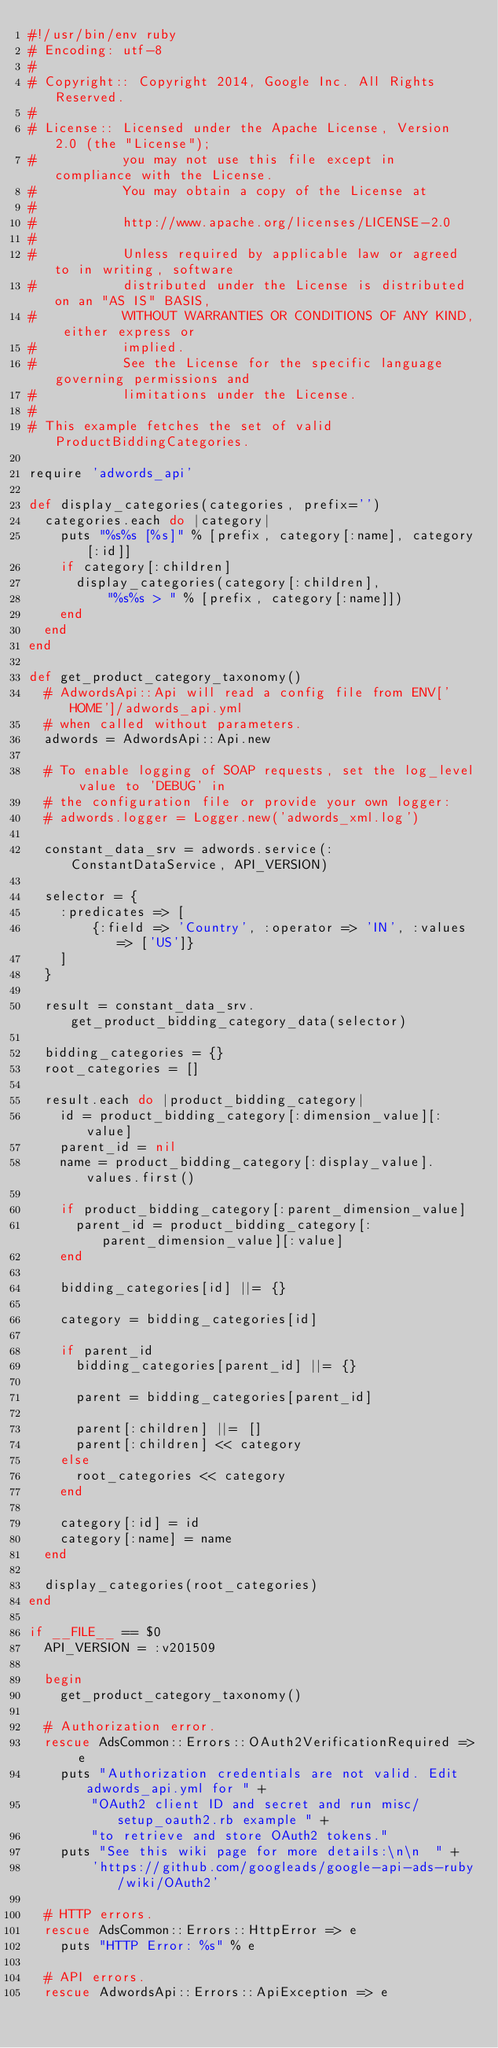Convert code to text. <code><loc_0><loc_0><loc_500><loc_500><_Ruby_>#!/usr/bin/env ruby
# Encoding: utf-8
#
# Copyright:: Copyright 2014, Google Inc. All Rights Reserved.
#
# License:: Licensed under the Apache License, Version 2.0 (the "License");
#           you may not use this file except in compliance with the License.
#           You may obtain a copy of the License at
#
#           http://www.apache.org/licenses/LICENSE-2.0
#
#           Unless required by applicable law or agreed to in writing, software
#           distributed under the License is distributed on an "AS IS" BASIS,
#           WITHOUT WARRANTIES OR CONDITIONS OF ANY KIND, either express or
#           implied.
#           See the License for the specific language governing permissions and
#           limitations under the License.
#
# This example fetches the set of valid ProductBiddingCategories.

require 'adwords_api'

def display_categories(categories, prefix='')
  categories.each do |category|
    puts "%s%s [%s]" % [prefix, category[:name], category[:id]]
    if category[:children]
      display_categories(category[:children],
          "%s%s > " % [prefix, category[:name]])
    end
  end
end

def get_product_category_taxonomy()
  # AdwordsApi::Api will read a config file from ENV['HOME']/adwords_api.yml
  # when called without parameters.
  adwords = AdwordsApi::Api.new

  # To enable logging of SOAP requests, set the log_level value to 'DEBUG' in
  # the configuration file or provide your own logger:
  # adwords.logger = Logger.new('adwords_xml.log')

  constant_data_srv = adwords.service(:ConstantDataService, API_VERSION)

  selector = {
    :predicates => [
        {:field => 'Country', :operator => 'IN', :values => ['US']}
    ]
  }

  result = constant_data_srv.get_product_bidding_category_data(selector)

  bidding_categories = {}
  root_categories = []

  result.each do |product_bidding_category|
    id = product_bidding_category[:dimension_value][:value]
    parent_id = nil
    name = product_bidding_category[:display_value].values.first()

    if product_bidding_category[:parent_dimension_value]
      parent_id = product_bidding_category[:parent_dimension_value][:value]
    end

    bidding_categories[id] ||= {}

    category = bidding_categories[id]

    if parent_id
      bidding_categories[parent_id] ||= {}

      parent = bidding_categories[parent_id]

      parent[:children] ||= []
      parent[:children] << category
    else
      root_categories << category
    end

    category[:id] = id
    category[:name] = name
  end

  display_categories(root_categories)
end

if __FILE__ == $0
  API_VERSION = :v201509

  begin
    get_product_category_taxonomy()

  # Authorization error.
  rescue AdsCommon::Errors::OAuth2VerificationRequired => e
    puts "Authorization credentials are not valid. Edit adwords_api.yml for " +
        "OAuth2 client ID and secret and run misc/setup_oauth2.rb example " +
        "to retrieve and store OAuth2 tokens."
    puts "See this wiki page for more details:\n\n  " +
        'https://github.com/googleads/google-api-ads-ruby/wiki/OAuth2'

  # HTTP errors.
  rescue AdsCommon::Errors::HttpError => e
    puts "HTTP Error: %s" % e

  # API errors.
  rescue AdwordsApi::Errors::ApiException => e</code> 